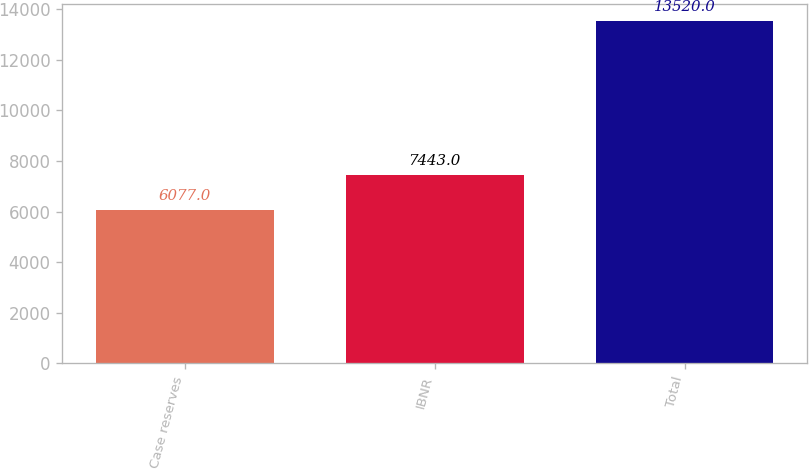Convert chart. <chart><loc_0><loc_0><loc_500><loc_500><bar_chart><fcel>Case reserves<fcel>IBNR<fcel>Total<nl><fcel>6077<fcel>7443<fcel>13520<nl></chart> 